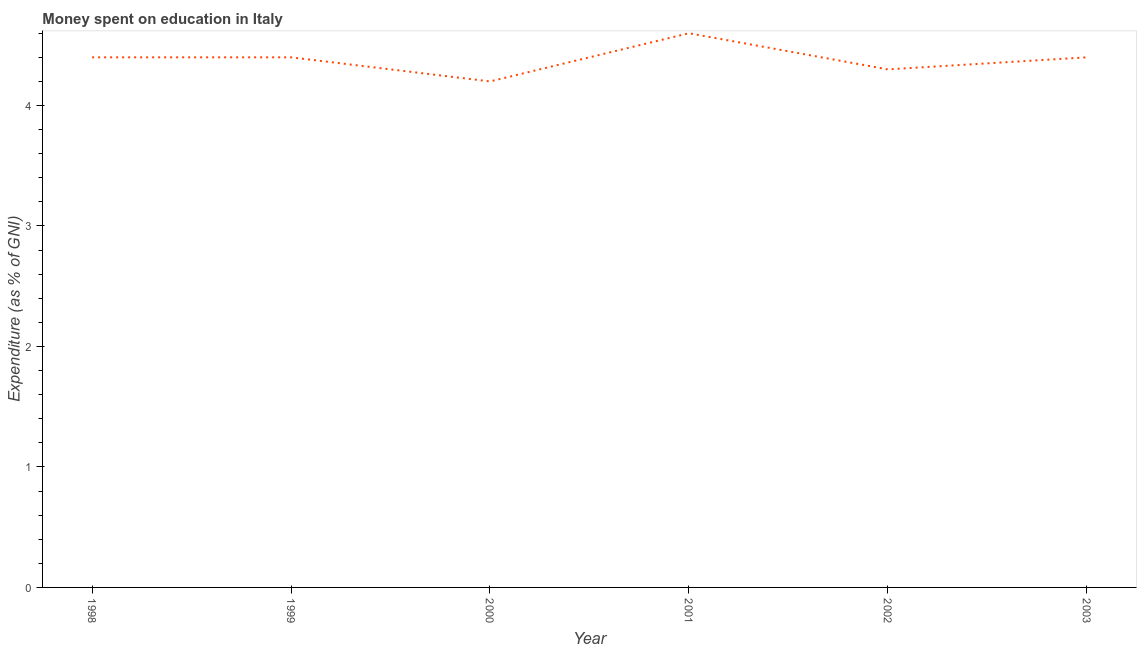What is the expenditure on education in 1999?
Provide a succinct answer. 4.4. In which year was the expenditure on education maximum?
Provide a succinct answer. 2001. In which year was the expenditure on education minimum?
Keep it short and to the point. 2000. What is the sum of the expenditure on education?
Your response must be concise. 26.3. What is the difference between the expenditure on education in 2000 and 2002?
Your answer should be compact. -0.1. What is the average expenditure on education per year?
Keep it short and to the point. 4.38. What is the median expenditure on education?
Your answer should be compact. 4.4. Do a majority of the years between 1998 and 2003 (inclusive) have expenditure on education greater than 1 %?
Make the answer very short. Yes. What is the ratio of the expenditure on education in 1998 to that in 2000?
Keep it short and to the point. 1.05. What is the difference between the highest and the second highest expenditure on education?
Keep it short and to the point. 0.2. What is the difference between the highest and the lowest expenditure on education?
Provide a short and direct response. 0.4. Does the graph contain grids?
Offer a terse response. No. What is the title of the graph?
Provide a succinct answer. Money spent on education in Italy. What is the label or title of the X-axis?
Your response must be concise. Year. What is the label or title of the Y-axis?
Give a very brief answer. Expenditure (as % of GNI). What is the Expenditure (as % of GNI) of 1998?
Offer a terse response. 4.4. What is the Expenditure (as % of GNI) in 1999?
Provide a succinct answer. 4.4. What is the Expenditure (as % of GNI) of 2001?
Ensure brevity in your answer.  4.6. What is the Expenditure (as % of GNI) in 2002?
Offer a terse response. 4.3. What is the difference between the Expenditure (as % of GNI) in 1998 and 1999?
Make the answer very short. 0. What is the difference between the Expenditure (as % of GNI) in 1998 and 2000?
Provide a short and direct response. 0.2. What is the difference between the Expenditure (as % of GNI) in 1998 and 2001?
Your answer should be compact. -0.2. What is the difference between the Expenditure (as % of GNI) in 1999 and 2002?
Offer a terse response. 0.1. What is the difference between the Expenditure (as % of GNI) in 2000 and 2001?
Your answer should be very brief. -0.4. What is the difference between the Expenditure (as % of GNI) in 2001 and 2002?
Make the answer very short. 0.3. What is the ratio of the Expenditure (as % of GNI) in 1998 to that in 2000?
Provide a short and direct response. 1.05. What is the ratio of the Expenditure (as % of GNI) in 1998 to that in 2002?
Give a very brief answer. 1.02. What is the ratio of the Expenditure (as % of GNI) in 1999 to that in 2000?
Your response must be concise. 1.05. What is the ratio of the Expenditure (as % of GNI) in 1999 to that in 2001?
Provide a succinct answer. 0.96. What is the ratio of the Expenditure (as % of GNI) in 2000 to that in 2003?
Provide a succinct answer. 0.95. What is the ratio of the Expenditure (as % of GNI) in 2001 to that in 2002?
Provide a succinct answer. 1.07. What is the ratio of the Expenditure (as % of GNI) in 2001 to that in 2003?
Offer a very short reply. 1.04. 